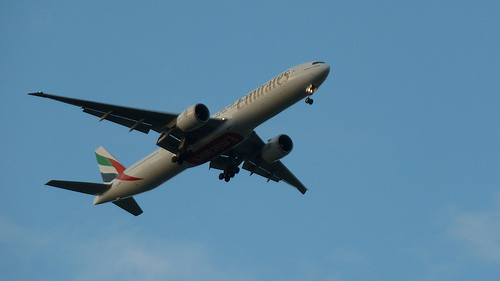Are there either fences or zebras? No, the image does not contain any fences or zebras; it solely focuses on the airplane in flight. 